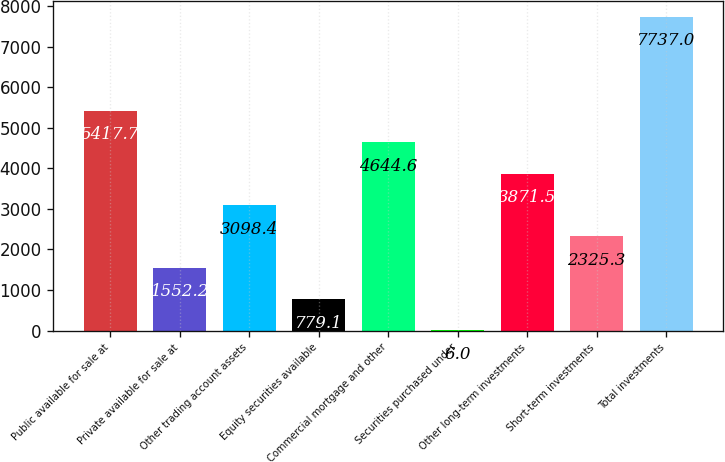Convert chart to OTSL. <chart><loc_0><loc_0><loc_500><loc_500><bar_chart><fcel>Public available for sale at<fcel>Private available for sale at<fcel>Other trading account assets<fcel>Equity securities available<fcel>Commercial mortgage and other<fcel>Securities purchased under<fcel>Other long-term investments<fcel>Short-term investments<fcel>Total investments<nl><fcel>5417.7<fcel>1552.2<fcel>3098.4<fcel>779.1<fcel>4644.6<fcel>6<fcel>3871.5<fcel>2325.3<fcel>7737<nl></chart> 